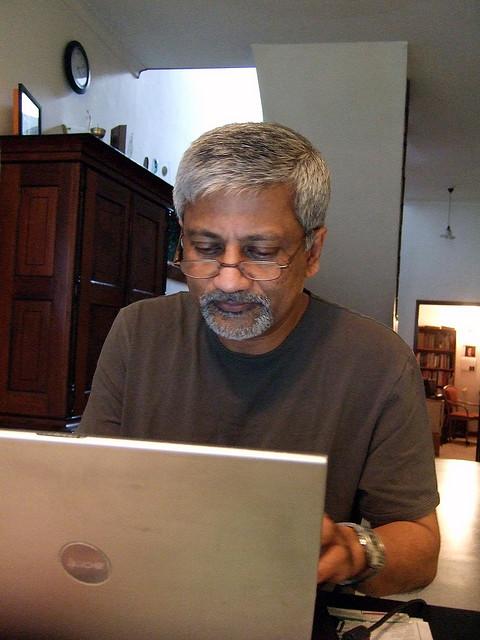Is this person wearing glasses?
Short answer required. Yes. What kind of computer is this?
Give a very brief answer. Dell. Is the man checking his e-mail?
Be succinct. Yes. Does he have glasses?
Answer briefly. Yes. What brand is this computer?
Keep it brief. Dell. 